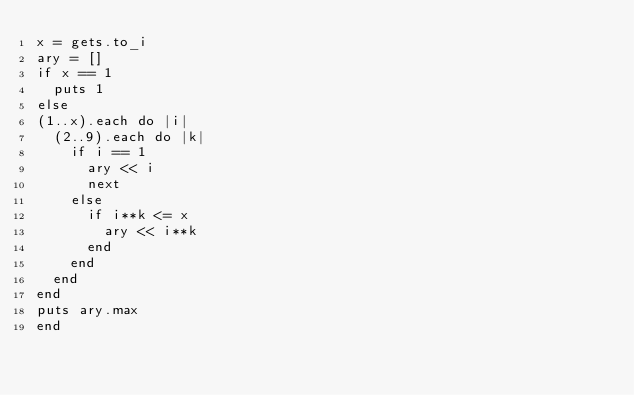<code> <loc_0><loc_0><loc_500><loc_500><_Ruby_>x = gets.to_i
ary = []
if x == 1
  puts 1
else
(1..x).each do |i|
  (2..9).each do |k|
    if i == 1
      ary << i
      next
    else
      if i**k <= x
        ary << i**k
      end
    end  
  end
end
puts ary.max
end
</code> 